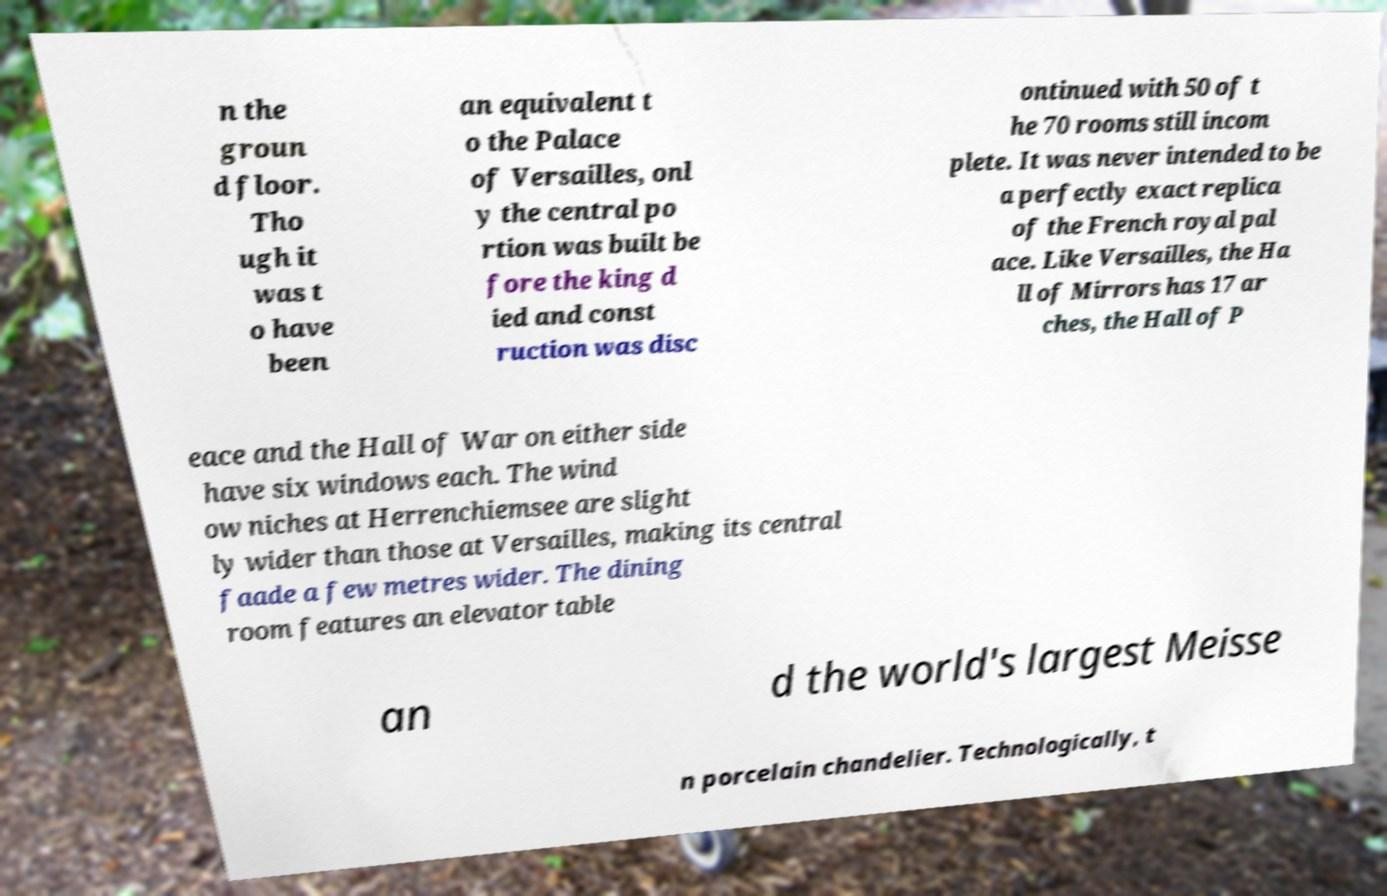For documentation purposes, I need the text within this image transcribed. Could you provide that? n the groun d floor. Tho ugh it was t o have been an equivalent t o the Palace of Versailles, onl y the central po rtion was built be fore the king d ied and const ruction was disc ontinued with 50 of t he 70 rooms still incom plete. It was never intended to be a perfectly exact replica of the French royal pal ace. Like Versailles, the Ha ll of Mirrors has 17 ar ches, the Hall of P eace and the Hall of War on either side have six windows each. The wind ow niches at Herrenchiemsee are slight ly wider than those at Versailles, making its central faade a few metres wider. The dining room features an elevator table an d the world's largest Meisse n porcelain chandelier. Technologically, t 